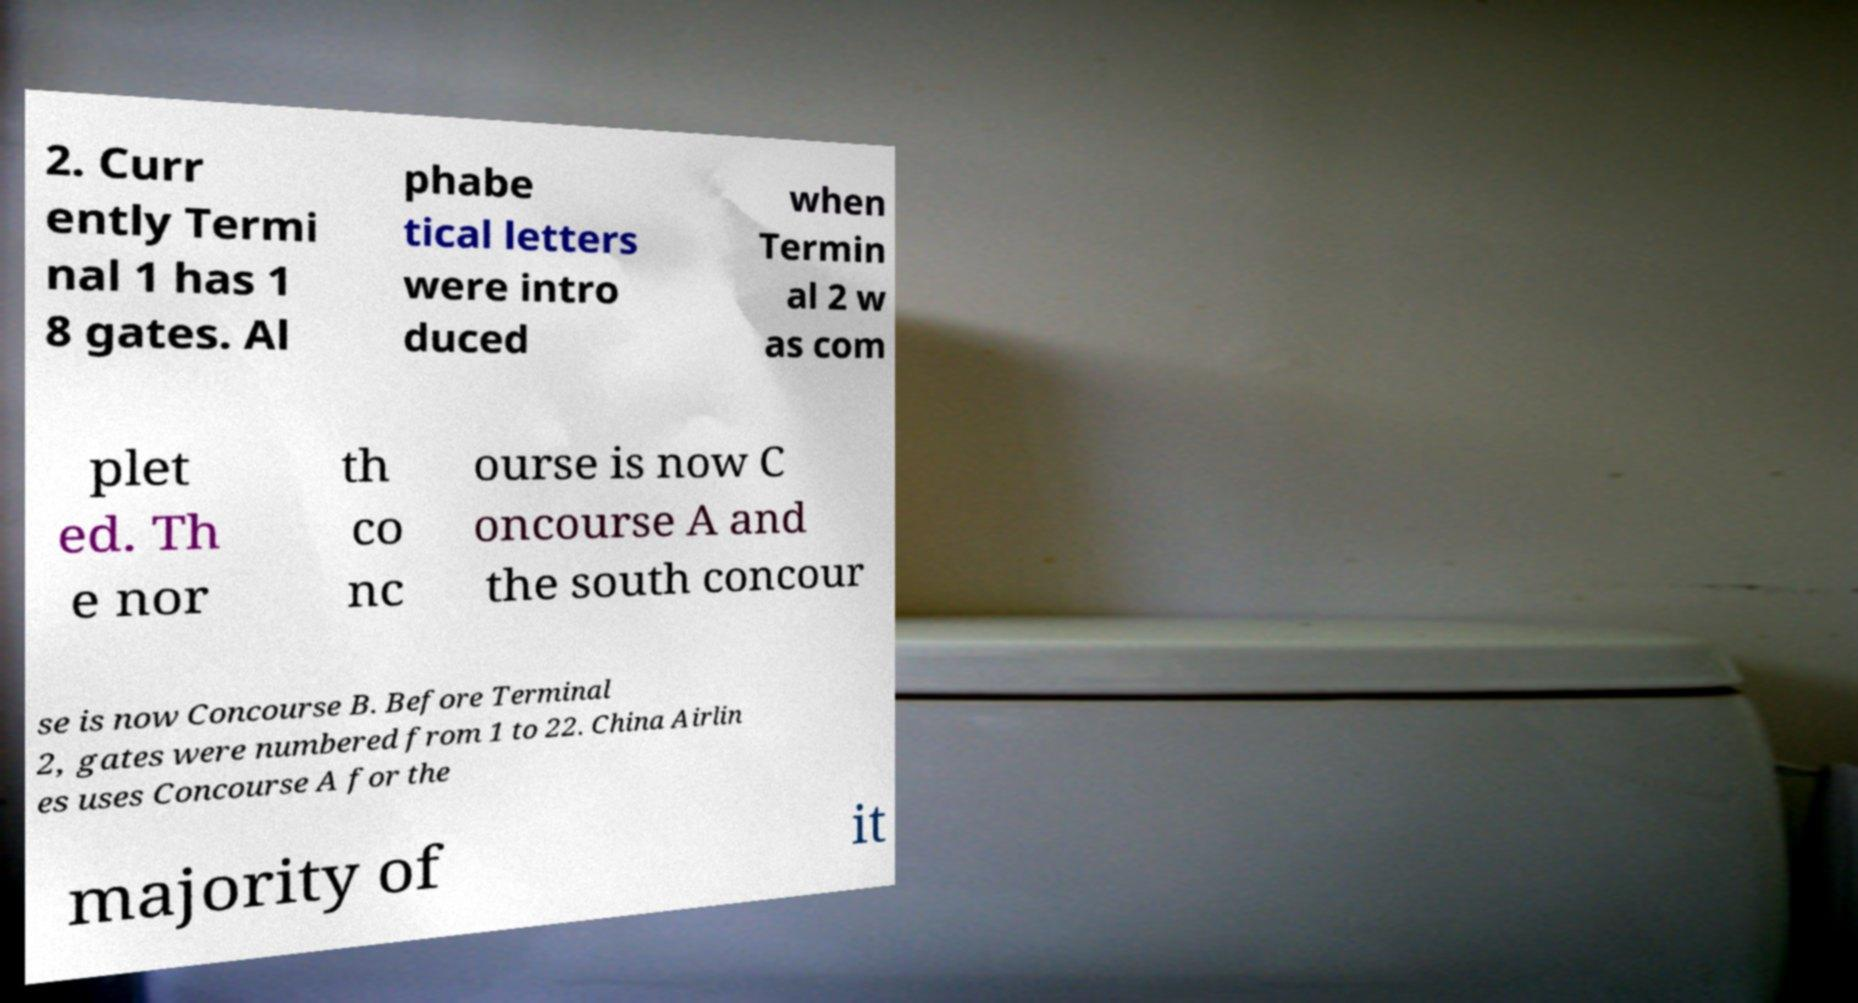Could you extract and type out the text from this image? 2. Curr ently Termi nal 1 has 1 8 gates. Al phabe tical letters were intro duced when Termin al 2 w as com plet ed. Th e nor th co nc ourse is now C oncourse A and the south concour se is now Concourse B. Before Terminal 2, gates were numbered from 1 to 22. China Airlin es uses Concourse A for the majority of it 